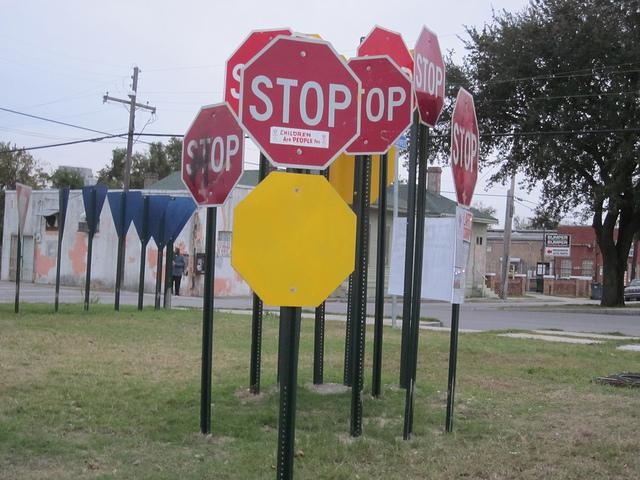What is the purpose of this signage? stopping 